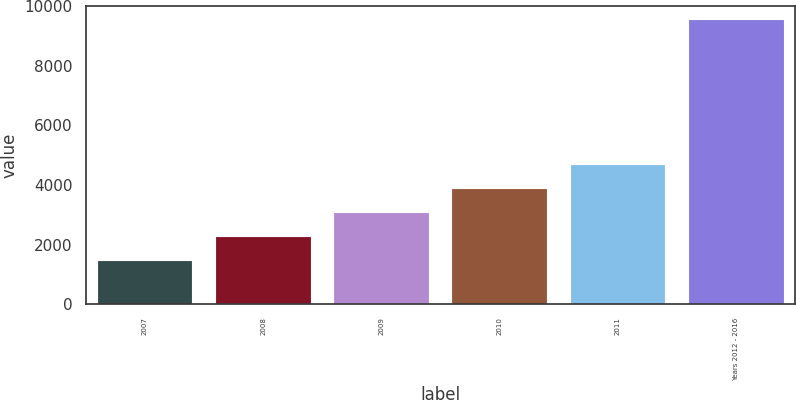Convert chart to OTSL. <chart><loc_0><loc_0><loc_500><loc_500><bar_chart><fcel>2007<fcel>2008<fcel>2009<fcel>2010<fcel>2011<fcel>Years 2012 - 2016<nl><fcel>1440<fcel>2249<fcel>3058<fcel>3867<fcel>4676<fcel>9530<nl></chart> 